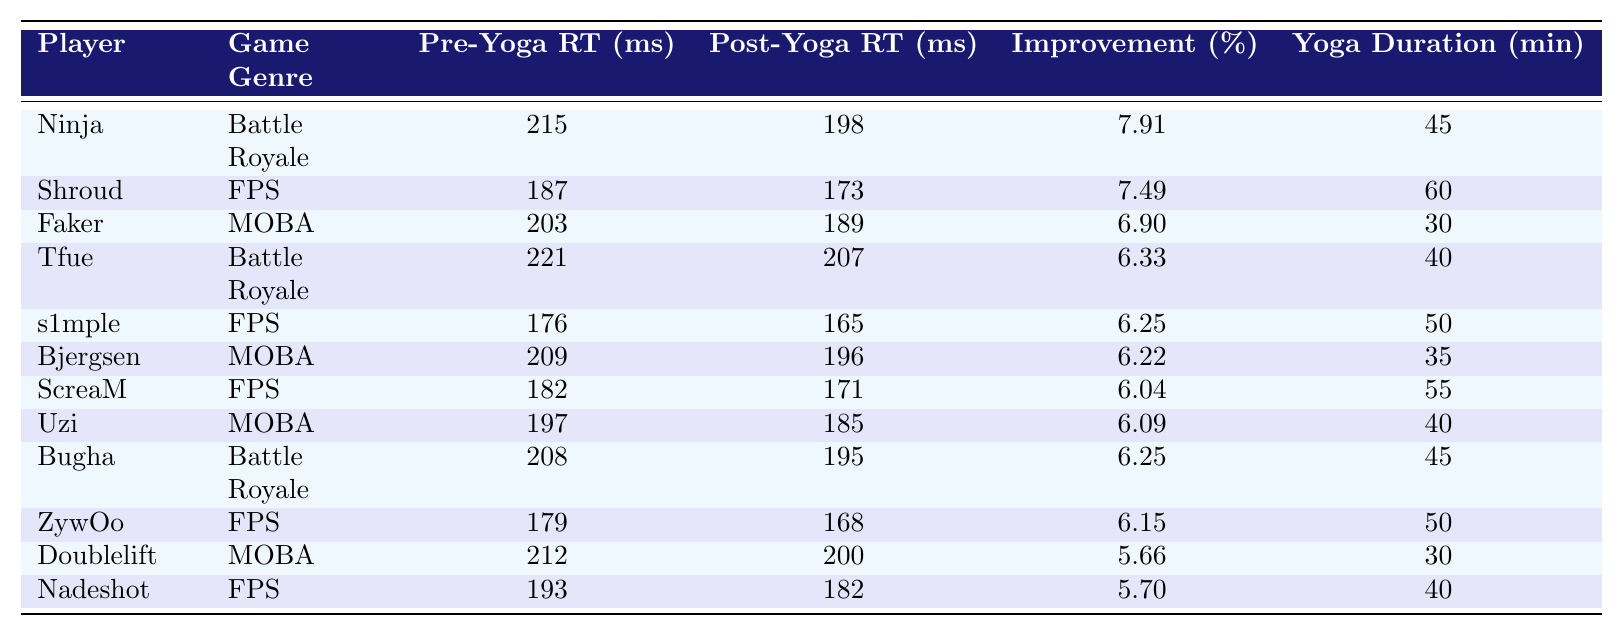What is the pre-yoga reaction time of Shroud? From the table, we can see that Shroud's pre-yoga reaction time is listed under the "Pre-Yoga Reaction Time (ms)" column, which shows a value of 187 ms.
Answer: 187 ms Which player had the highest improvement in reaction time? By comparing the "Improvement (%)" column for each player, we see that Ninja has the highest improvement of 7.91%.
Answer: Ninja What is the post-yoga reaction time for players in the FPS genre? We can identify the players in the FPS genre (Shroud, s1mple, ScreaM, ZywOo, Nadeshot) and find their corresponding post-yoga reaction times: 173, 165, 171, 168, and 182 ms.
Answer: 173, 165, 171, 168, 182 ms What is the average pre-yoga reaction time for players in the MOBA genre? The pre-yoga reaction times for the MOBA players (Faker, Bjergsen, Uzi, Doublelift) are 203, 209, 197, and 212 ms. Adding these gives 203 + 209 + 197 + 212 = 821 ms, and dividing by 4 yields an average of 205.25 ms.
Answer: 205.25 ms Did all players experience an improvement in their reaction time after yoga? We can look at the "Improvement (%)" column; all values are positive, confirming that every player experienced an improvement in their reaction time after yoga.
Answer: Yes Which game genre had the lowest average improvement percentage? To find this, we check the improvements for Battle Royale (7.25%), FPS (6.57%), and MOBA (6.72%) by averaging. Battle Royale has the lowest average improvement percentage.
Answer: Battle Royale What is the total yoga session duration for all players listed? We sum the yoga session durations (45 + 60 + 30 + 40 + 50 + 35 + 55 + 40 + 45 + 50 + 30 + 40) which equals 540 minutes.
Answer: 540 minutes Is the post-yoga reaction time of Tfue better than that of Ninja? Tfue's post-yoga reaction time is 207 ms, while Ninja's is 198 ms. Since 198 ms is less than 207 ms, Ninja has a better post-yoga reaction time.
Answer: No What player improved their reaction time the least after yoga? By examining the "Improvement (%)" column, we see that Doublelift showed the least improvement at 5.66%.
Answer: Doublelift What percentage improvement did players in the FPS genre achieve on average? The improvements are Shroud (7.49%), s1mple (6.25%), ScreaM (6.04%), ZywOo (6.15%), and Nadeshot (5.70%). Their average is (7.49 + 6.25 + 6.04 + 6.15 + 5.70) / 5 = 6.43%.
Answer: 6.43% 